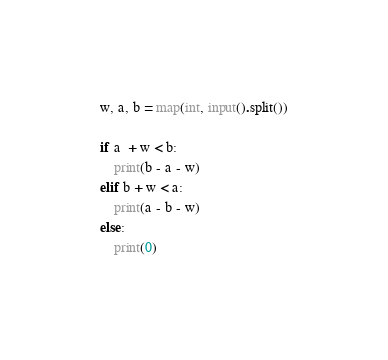<code> <loc_0><loc_0><loc_500><loc_500><_Python_>w, a, b = map(int, input().split())

if a  + w < b:
    print(b - a - w)
elif b + w < a:
    print(a - b - w)
else:
    print(0)
</code> 